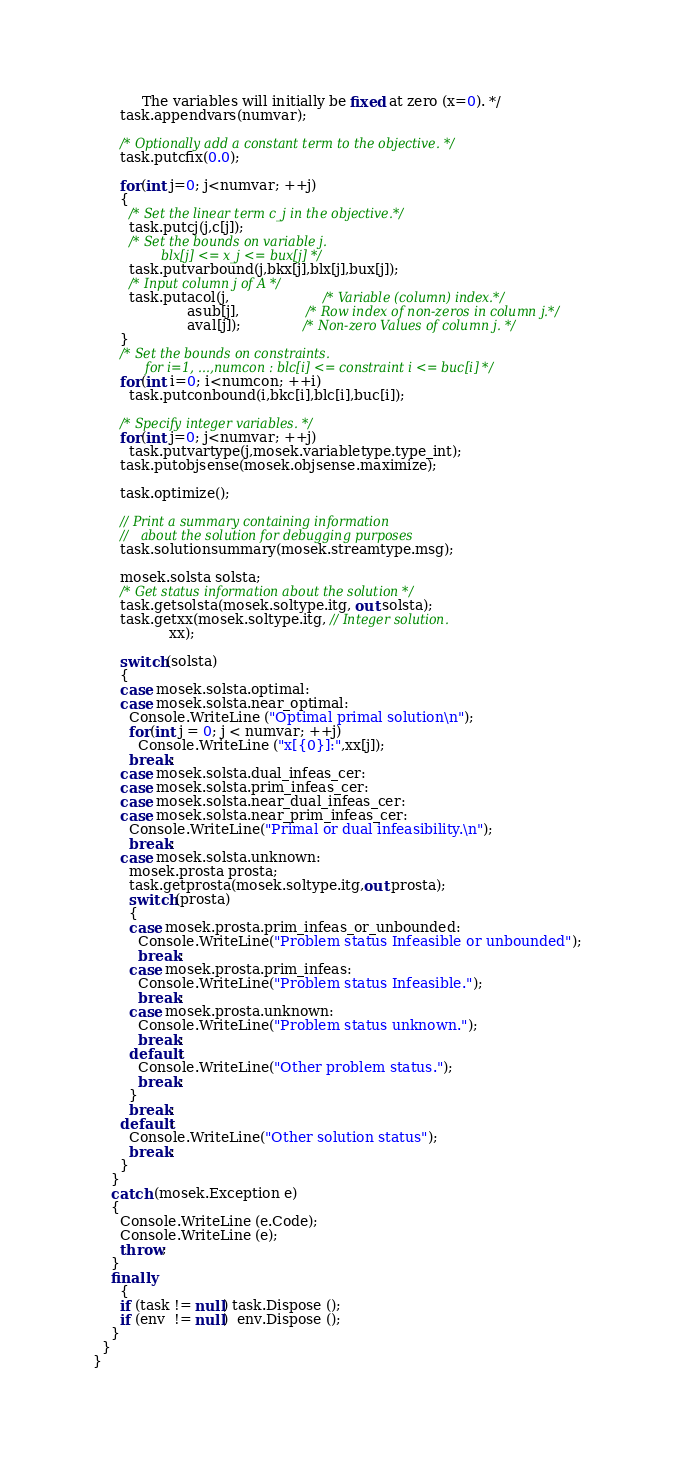Convert code to text. <code><loc_0><loc_0><loc_500><loc_500><_C#_>           The variables will initially be fixed at zero (x=0). */
      task.appendvars(numvar);

      /* Optionally add a constant term to the objective. */
      task.putcfix(0.0);

      for(int j=0; j<numvar; ++j)
      {
        /* Set the linear term c_j in the objective.*/  
        task.putcj(j,c[j]);
        /* Set the bounds on variable j.
                 blx[j] <= x_j <= bux[j] */
        task.putvarbound(j,bkx[j],blx[j],bux[j]);
        /* Input column j of A */   
        task.putacol(j,                     /* Variable (column) index.*/
                     asub[j],               /* Row index of non-zeros in column j.*/
                     aval[j]);              /* Non-zero Values of column j. */
      }
      /* Set the bounds on constraints.
             for i=1, ...,numcon : blc[i] <= constraint i <= buc[i] */
      for(int i=0; i<numcon; ++i)
        task.putconbound(i,bkc[i],blc[i],buc[i]);
            
      /* Specify integer variables. */
      for(int j=0; j<numvar; ++j)
        task.putvartype(j,mosek.variabletype.type_int);
      task.putobjsense(mosek.objsense.maximize);
           
      task.optimize();
             
      // Print a summary containing information
      //   about the solution for debugging purposes
      task.solutionsummary(mosek.streamtype.msg);
      
      mosek.solsta solsta;
      /* Get status information about the solution */
      task.getsolsta(mosek.soltype.itg, out solsta);    
      task.getxx(mosek.soltype.itg, // Integer solution.     
                 xx);
      
      switch(solsta)
      {
      case mosek.solsta.optimal:
      case mosek.solsta.near_optimal:      
        Console.WriteLine ("Optimal primal solution\n");
        for(int j = 0; j < numvar; ++j)
          Console.WriteLine ("x[{0}]:",xx[j]);
        break;
      case mosek.solsta.dual_infeas_cer:
      case mosek.solsta.prim_infeas_cer:
      case mosek.solsta.near_dual_infeas_cer:
      case mosek.solsta.near_prim_infeas_cer:  
        Console.WriteLine("Primal or dual infeasibility.\n");
        break;
      case mosek.solsta.unknown:
        mosek.prosta prosta;
        task.getprosta(mosek.soltype.itg,out prosta);
        switch(prosta)
        {
        case mosek.prosta.prim_infeas_or_unbounded:
          Console.WriteLine("Problem status Infeasible or unbounded");
          break;
        case mosek.prosta.prim_infeas:
          Console.WriteLine("Problem status Infeasible.");
          break;
        case mosek.prosta.unknown:
          Console.WriteLine("Problem status unknown.");
          break;
        default:
          Console.WriteLine("Other problem status.");
          break;
        }
        break;
      default:
        Console.WriteLine("Other solution status");
        break;
      }
    }
    catch (mosek.Exception e)
    {
      Console.WriteLine (e.Code);
      Console.WriteLine (e);
      throw;
    }
    finally
      {
      if (task != null) task.Dispose ();
      if (env  != null)  env.Dispose ();
    }
  }      
}
</code> 